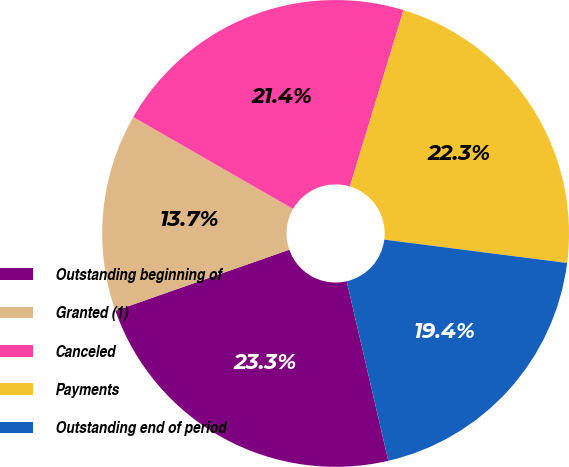Convert chart to OTSL. <chart><loc_0><loc_0><loc_500><loc_500><pie_chart><fcel>Outstanding beginning of<fcel>Granted (1)<fcel>Canceled<fcel>Payments<fcel>Outstanding end of period<nl><fcel>23.25%<fcel>13.68%<fcel>21.39%<fcel>22.32%<fcel>19.35%<nl></chart> 